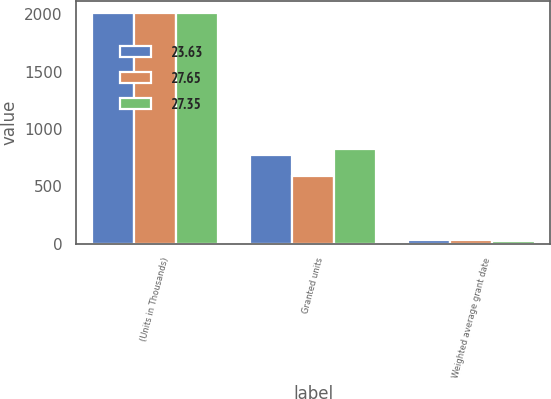Convert chart. <chart><loc_0><loc_0><loc_500><loc_500><stacked_bar_chart><ecel><fcel>(Units in Thousands)<fcel>Granted units<fcel>Weighted average grant date<nl><fcel>23.63<fcel>2013<fcel>774<fcel>27.65<nl><fcel>27.65<fcel>2012<fcel>591<fcel>27.35<nl><fcel>27.35<fcel>2011<fcel>828<fcel>23.63<nl></chart> 